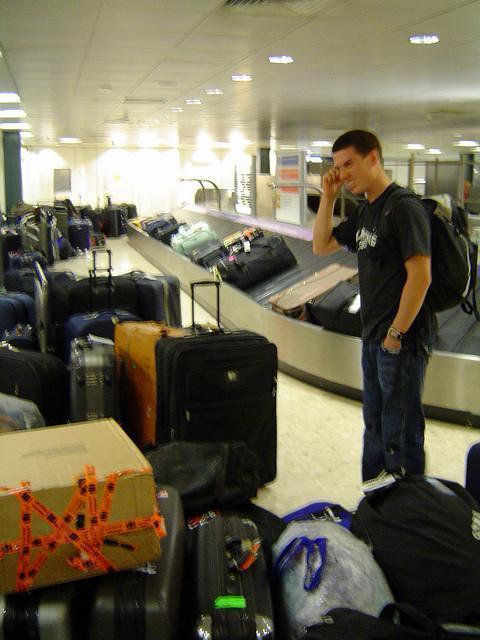How many suitcases are there?
Give a very brief answer. 8. 